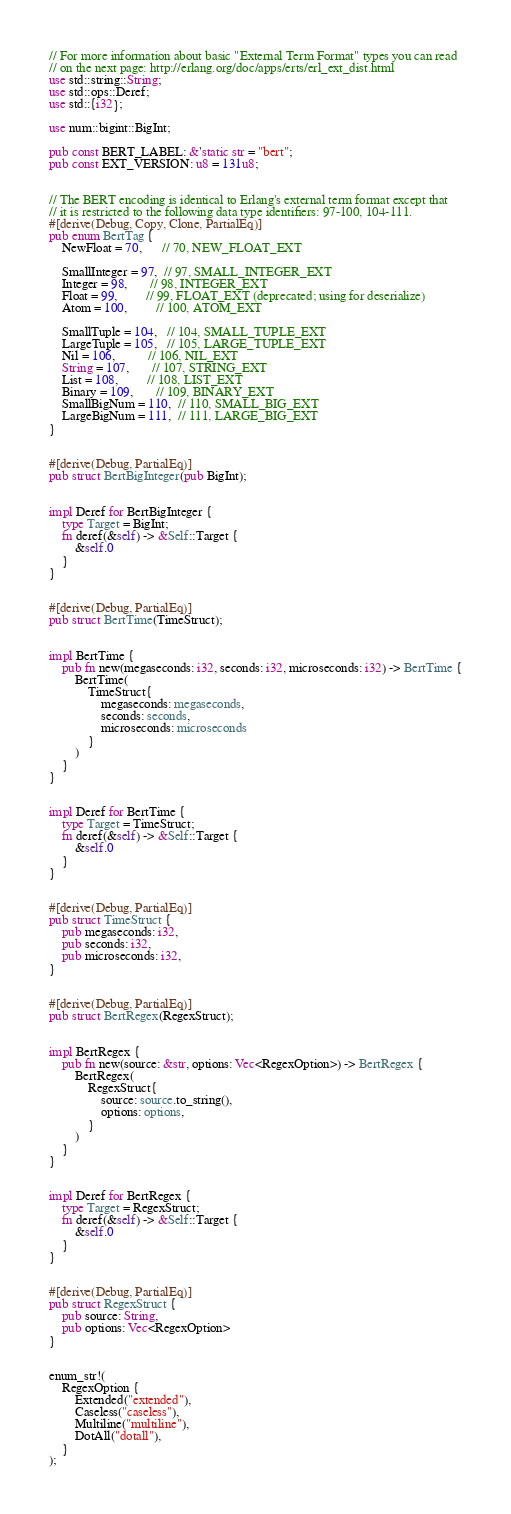<code> <loc_0><loc_0><loc_500><loc_500><_Rust_>// For more information about basic "External Term Format" types you can read
// on the next page: http://erlang.org/doc/apps/erts/erl_ext_dist.html
use std::string::String;
use std::ops::Deref;
use std::{i32};

use num::bigint::BigInt;

pub const BERT_LABEL: &'static str = "bert";
pub const EXT_VERSION: u8 = 131u8;


// The BERT encoding is identical to Erlang's external term format except that
// it is restricted to the following data type identifiers: 97-100, 104-111.
#[derive(Debug, Copy, Clone, PartialEq)]
pub enum BertTag {
    NewFloat = 70,      // 70, NEW_FLOAT_EXT

    SmallInteger = 97,  // 97, SMALL_INTEGER_EXT
    Integer = 98,       // 98, INTEGER_EXT
    Float = 99,         // 99, FLOAT_EXT (deprecated; using for deserialize)
    Atom = 100,         // 100, ATOM_EXT

    SmallTuple = 104,   // 104, SMALL_TUPLE_EXT
    LargeTuple = 105,   // 105, LARGE_TUPLE_EXT
    Nil = 106,          // 106, NIL_EXT
    String = 107,       // 107, STRING_EXT
    List = 108,         // 108, LIST_EXT
    Binary = 109,       // 109, BINARY_EXT
    SmallBigNum = 110,  // 110, SMALL_BIG_EXT
    LargeBigNum = 111,  // 111, LARGE_BIG_EXT
}


#[derive(Debug, PartialEq)]
pub struct BertBigInteger(pub BigInt);


impl Deref for BertBigInteger {
    type Target = BigInt;
    fn deref(&self) -> &Self::Target {
        &self.0
    }
}


#[derive(Debug, PartialEq)]
pub struct BertTime(TimeStruct);


impl BertTime {
    pub fn new(megaseconds: i32, seconds: i32, microseconds: i32) -> BertTime {
        BertTime(
            TimeStruct{
                megaseconds: megaseconds,
                seconds: seconds,
                microseconds: microseconds
            }
        )
    }
}


impl Deref for BertTime {
    type Target = TimeStruct;
    fn deref(&self) -> &Self::Target {
        &self.0
    }
}


#[derive(Debug, PartialEq)]
pub struct TimeStruct {
    pub megaseconds: i32,
    pub seconds: i32,
    pub microseconds: i32,
}


#[derive(Debug, PartialEq)]
pub struct BertRegex(RegexStruct);


impl BertRegex {
    pub fn new(source: &str, options: Vec<RegexOption>) -> BertRegex {
        BertRegex(
            RegexStruct{
                source: source.to_string(),
                options: options,
            }
        )
    }
}


impl Deref for BertRegex {
    type Target = RegexStruct;
    fn deref(&self) -> &Self::Target {
        &self.0
    }
}


#[derive(Debug, PartialEq)]
pub struct RegexStruct {
    pub source: String,
    pub options: Vec<RegexOption>
}


enum_str!(
    RegexOption {
        Extended("extended"),
        Caseless("caseless"),
        Multiline("multiline"),
        DotAll("dotall"),
    }
);
</code> 